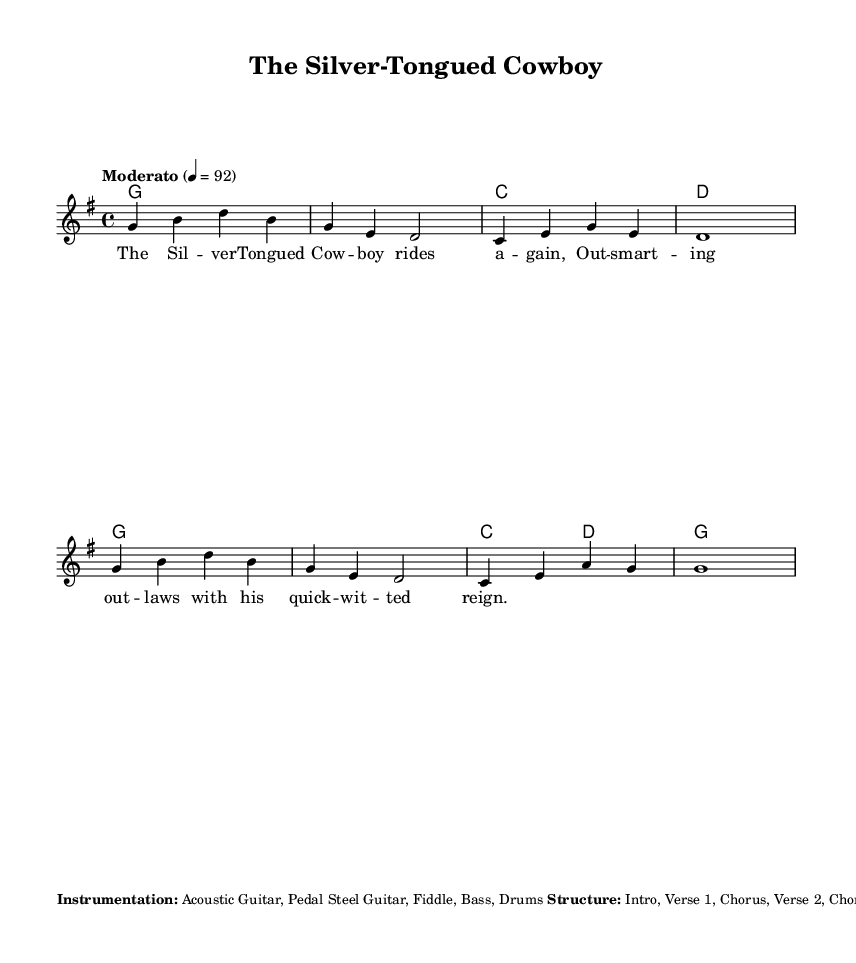What is the key signature of this music? The key signature is G major, which has one sharp (F#). This can be determined by examining the key signature indicated at the beginning of the sheet music.
Answer: G major What is the time signature of this music? The time signature is 4/4, which means there are four beats in each measure and the quarter note gets one beat. This is clearly marked at the beginning of the score.
Answer: 4/4 What is the tempo marking for this piece? The tempo marking is "Moderato," which typically conveys a moderate speed. It is indicated along with a metronome marking of 4 = 92, meaning 92 beats per minute. The tempo is stated above the staff.
Answer: Moderato How many verses are in this song? There are two verses in the structure of the song: Verse 1 and Verse 2, as shown in the additional notes section detailing the overall structure.
Answer: Two What instrument plays a solo after the second chorus? The fiddle plays a solo after the second chorus, as indicated in the additional notes section. This involves looking for specific mentions of instrumental sections in the notes.
Answer: Fiddle What is the mood suggested by the title "The Silver-Tongued Cowboy"? The title suggests a playful and charismatic mood, typically associated with a charming and witty character, a common portrayal in classic country songs. The title gives insight into the character's personality.
Answer: Playful How is the arrangement structured beyond the verses? The arrangement consists of an Intro, two verses, two choruses, a Bridge, and an Outro, providing a clear flow and form typical of classic country ballads. This is explicitly outlined in the additional notes section.
Answer: Intro, Verse 1, Chorus, Verse 2, Chorus, Bridge, Chorus, Outro 